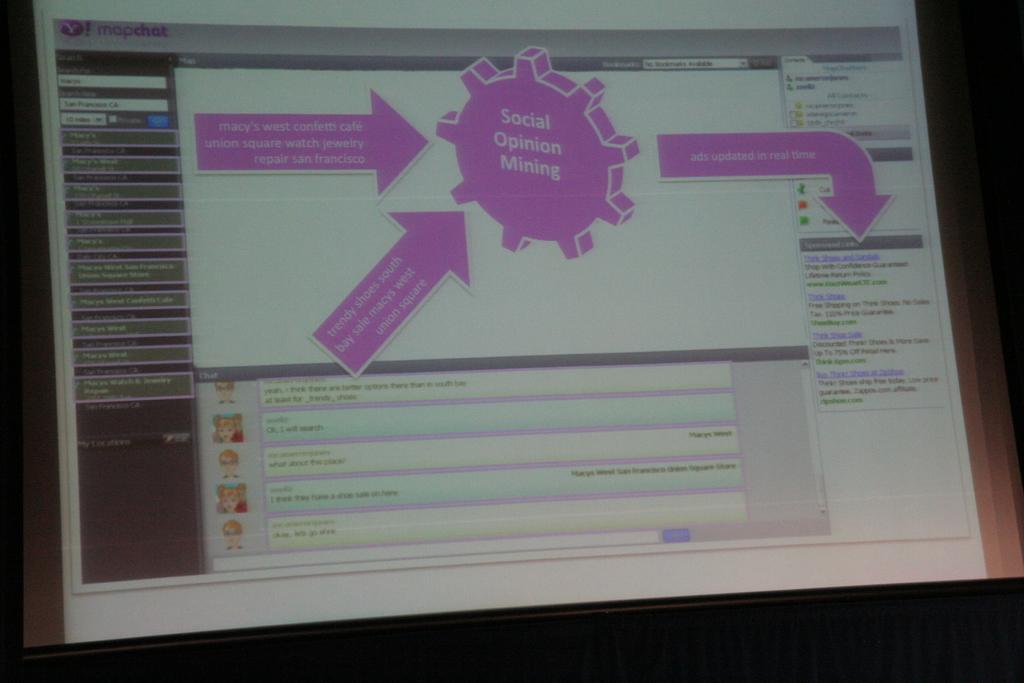What is the main object in the image? There is a screen in the image. What is displayed on the screen? The screen contains text. Is there any additional information on the screen? Yes, there is a label on the screen. What type of soap is shown on the screen in the image? There is no soap present on the screen in the image; it only contains text and a label. 